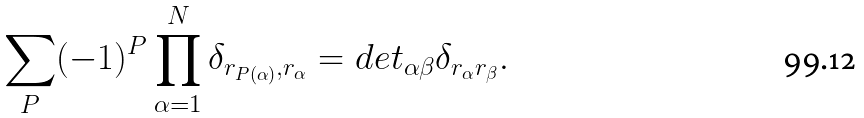Convert formula to latex. <formula><loc_0><loc_0><loc_500><loc_500>\sum _ { P } ( - 1 ) ^ { P } \prod _ { \alpha = 1 } ^ { N } \delta _ { r _ { P ( \alpha ) } , r _ { \alpha } } = d e t _ { \alpha \beta } \delta _ { r _ { \alpha } r _ { \beta } } .</formula> 